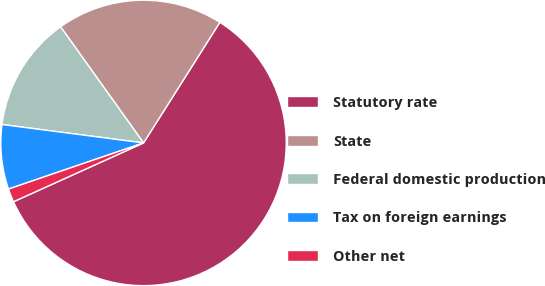<chart> <loc_0><loc_0><loc_500><loc_500><pie_chart><fcel>Statutory rate<fcel>State<fcel>Federal domestic production<fcel>Tax on foreign earnings<fcel>Other net<nl><fcel>59.26%<fcel>18.85%<fcel>13.07%<fcel>7.3%<fcel>1.52%<nl></chart> 